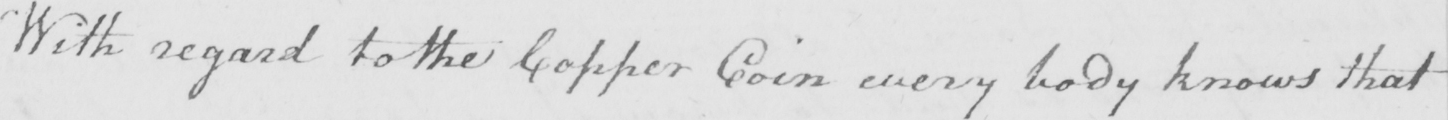What text is written in this handwritten line? With regard to the Copper Coin every body knows that 